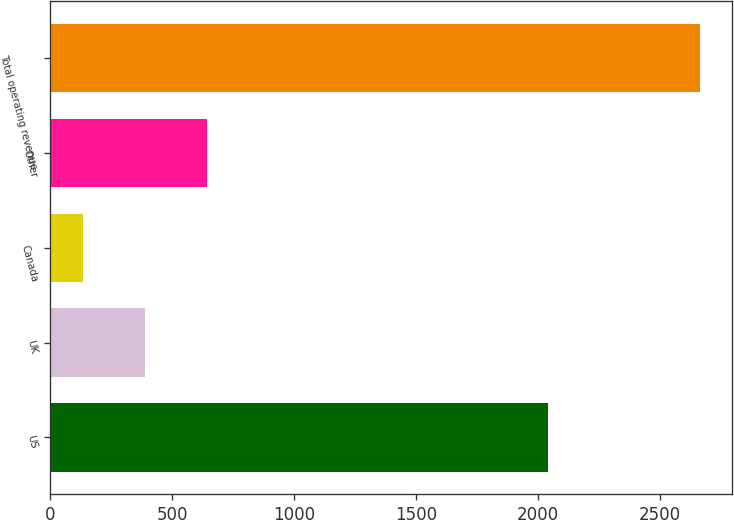Convert chart to OTSL. <chart><loc_0><loc_0><loc_500><loc_500><bar_chart><fcel>US<fcel>UK<fcel>Canada<fcel>Other<fcel>Total operating revenue<nl><fcel>2041.7<fcel>388.31<fcel>135.5<fcel>641.12<fcel>2663.6<nl></chart> 